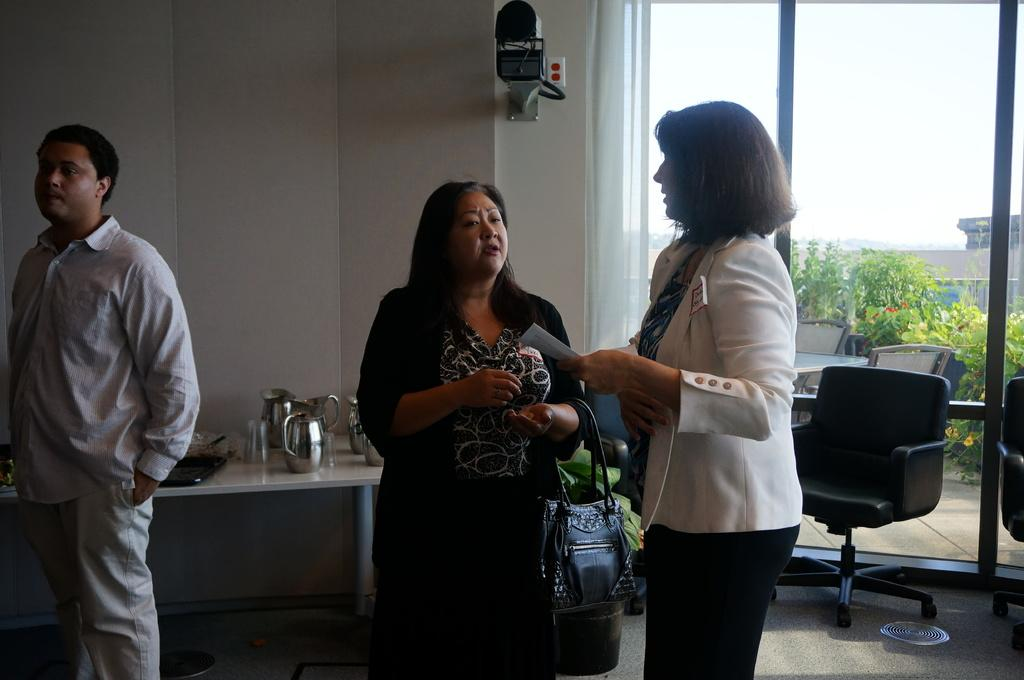What is happening in the image? There are people standing in the image. What objects can be seen on a table in the background? There are jars and glasses on a table in the background. What type of furniture is visible in the background? There are chairs in the background. What type of windows are present in the background? There are glass windows in the background. What can be seen through the glass windows? Trees are visible through the glass windows. How many fingers can be seen holding a bucket in the image? There is no bucket or fingers holding a bucket present in the image. Are there any women visible in the image? The provided facts do not mention the gender of the people in the image, so we cannot definitively answer whether there are any women visible. 